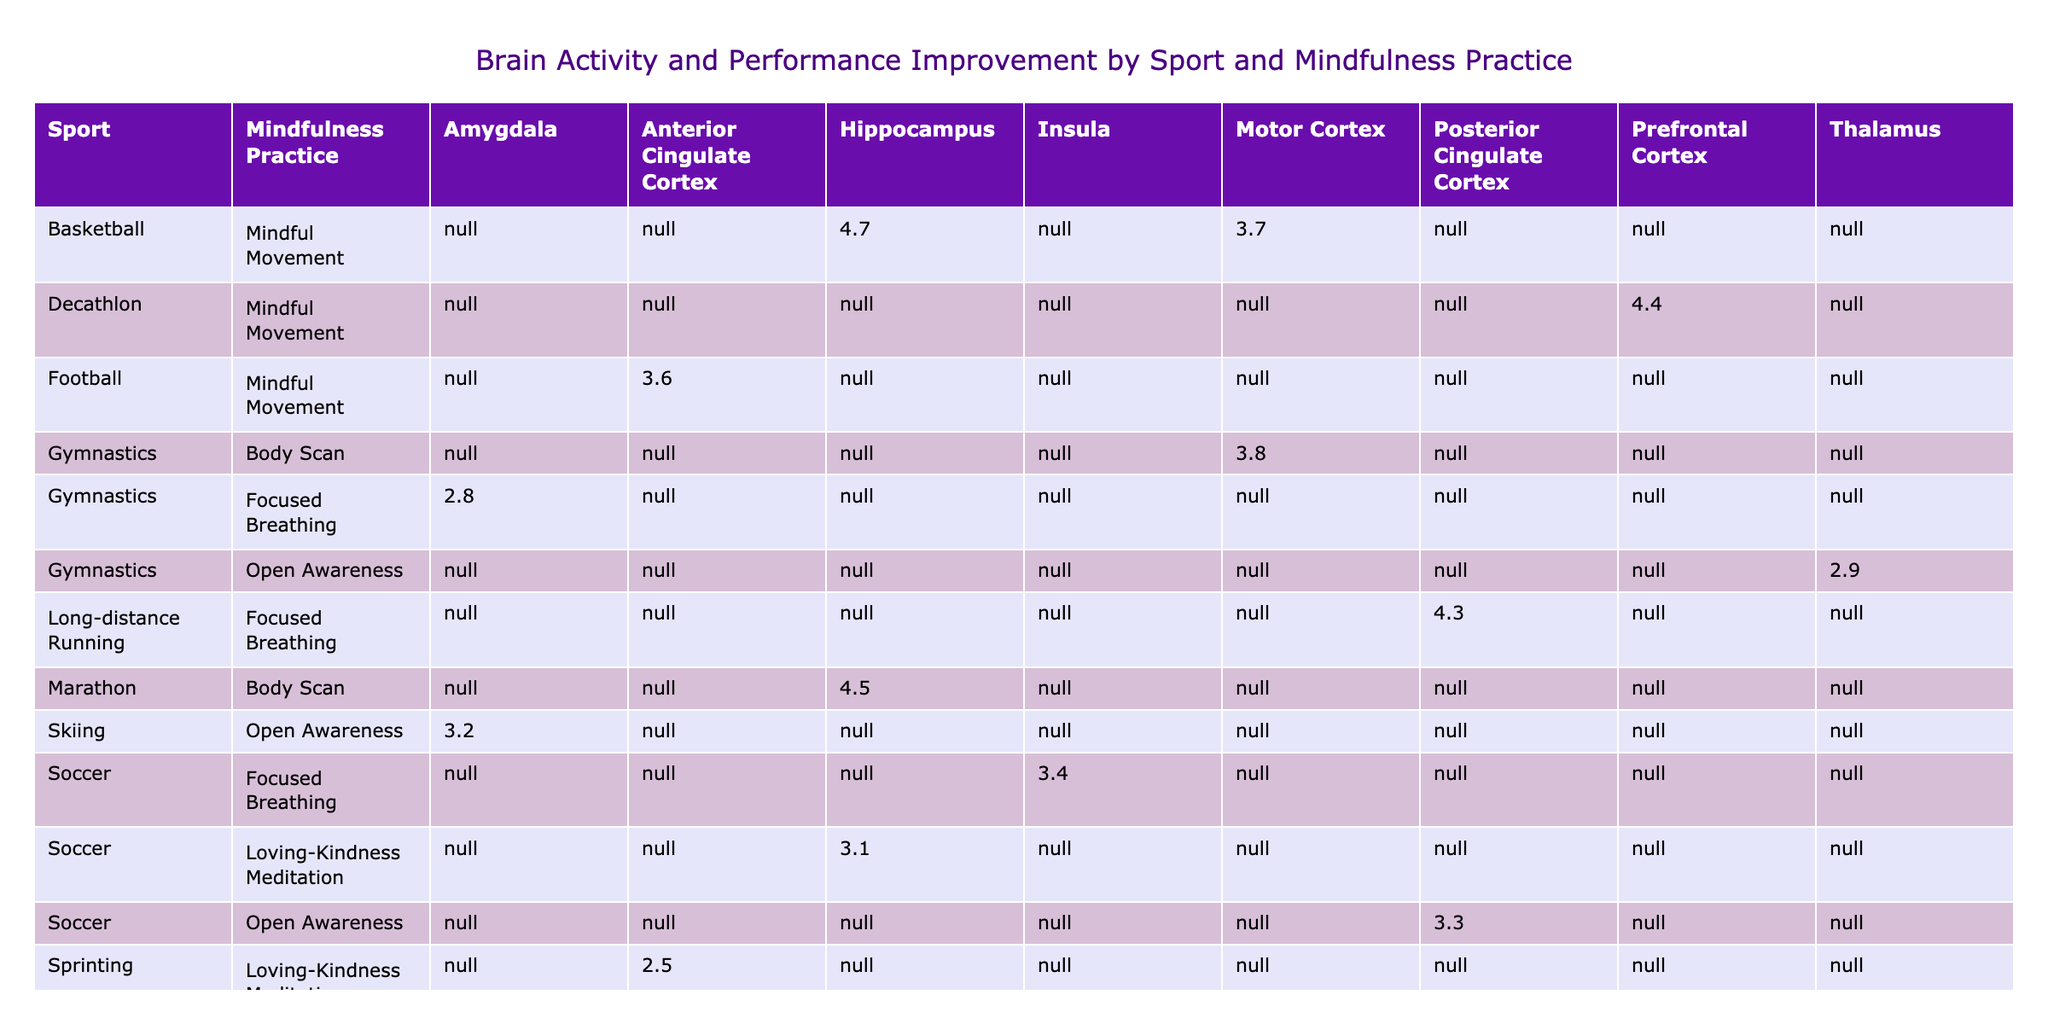What mindfulness practice resulted in the highest performance improvement for Tennis? The table shows that the combination of Visualization and the Prefrontal Cortex resulted in a performance improvement of 4.6%.
Answer: 4.6% Which brain region is associated with the highest performance improvement in Swimming? By examining the performance improvement percentages for Swimming, the Body Scan and the Prefrontal Cortex are linked, providing an improvement of 3.9%.
Answer: 3.9% Is Loving-Kindness Meditation effective across different sports? Yes, Loving-Kindness Meditation appears to contribute to performance improvements in multiple sports: 2.5% in Sprinting, 3.1% in Soccer, and 4.5% in Marathon running.
Answer: Yes What is the average performance improvement for athletes practicing Open Awareness across all sports? The performance improvement percentages for Open Awareness are: 3.3% for Soccer, 2.9% for Gymnastics, and 2.7% for Swimming. The average is (3.3 + 2.9 + 2.7) / 3 = 2.97%.
Answer: 2.97% Which athlete had the longest session duration with Mindful Movement in his practice? In examining the table, we find that Kevin Durant's session duration for Mindful Movement is 35 minutes, which is the longest reported.
Answer: 35 minutes What is the total performance improvement percentage for all Tennis practices included in the table? We add up the performance improvements for Tennis: 4.6% for Body Scan, 4.1% for Visualization, and 4.2% for Loving-Kindness Meditation, totaling to 4.6 + 4.1 + 4.2 = 13.0%.
Answer: 13.0% Do Sprinting athletes show a higher performance improvement than Swimming athletes on average? First, we find the performance improvements for Sprinting: 2.5%, 2.9%, and 3.8%, which gives an average of (2.5 + 2.9 + 3.8) / 3 = 3.05%. For Swimming, the average performance improvements are 3.2%, 3.9%, and 2.7%, calculating to (3.2 + 3.9 + 2.7) / 3 = 3.26%. Since 3.05% is less than 3.26%, the answer is no.
Answer: No Which mindfulness practice resulted in the lowest overall performance improvement percentage across all athlete types? After reviewing the performance improvement values, Loving-Kindness Meditation for Sprinting yielded the lowest result at 2.5%. Therefore, it is the mindfulness practice with the lowest overall performance improvement.
Answer: 2.5% 